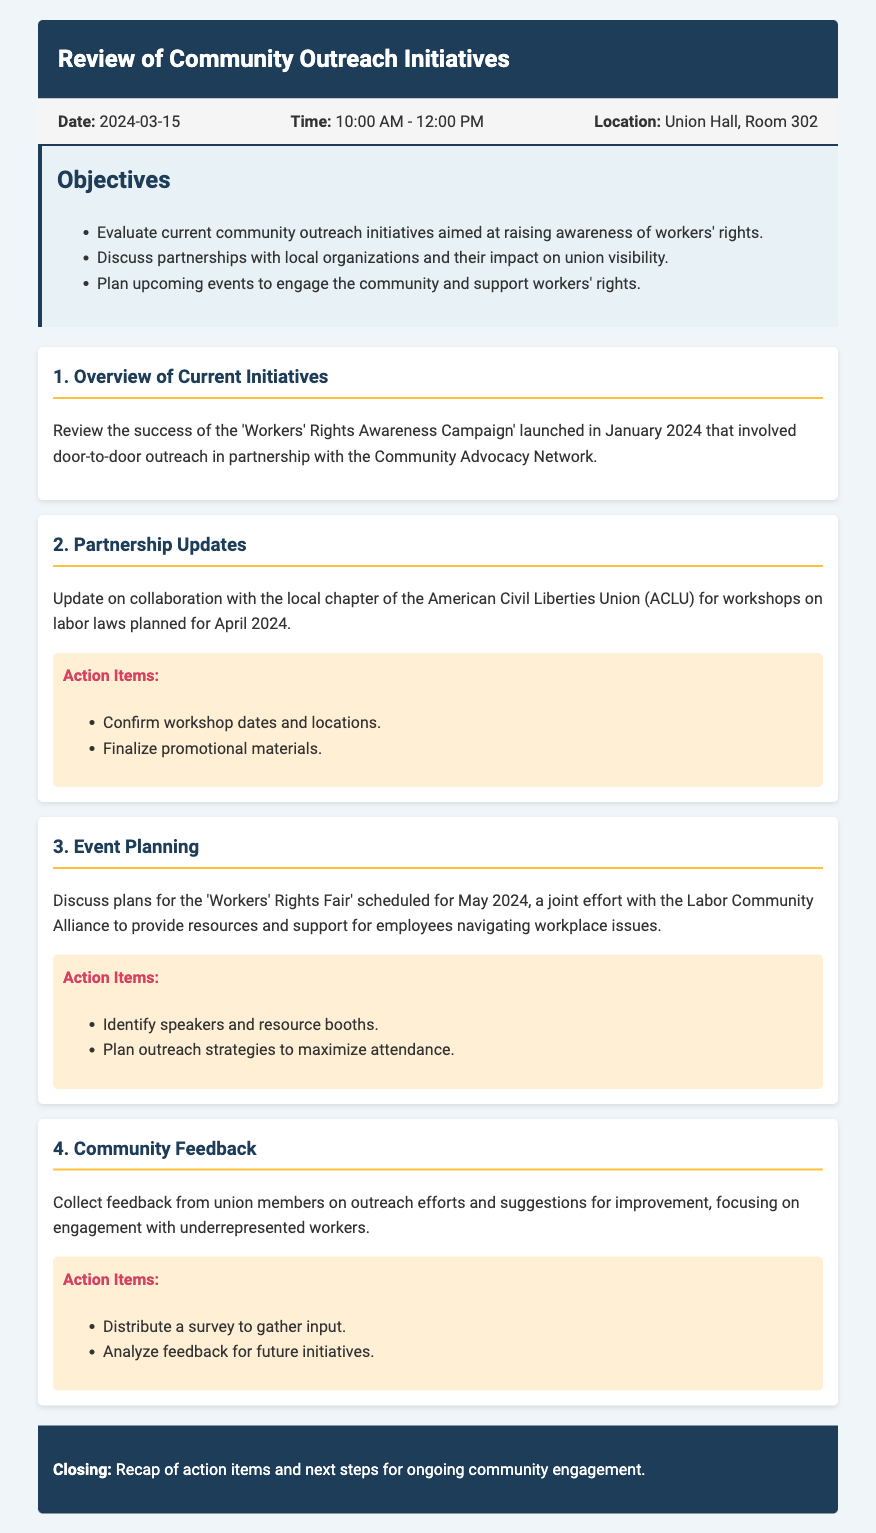What is the date of the meeting? The date of the meeting is stated in the meta-info section of the document.
Answer: 2024-03-15 What is the location of the meeting? The location of the meeting is mentioned in the meta-info section.
Answer: Union Hall, Room 302 What campaign was launched in January 2024? The overview of current initiatives mentions the name of the campaign launched in January.
Answer: Workers' Rights Awareness Campaign Who is collaborating with the union for workshops on labor laws? The partnership updates section specifies the organization the union is collaborating with.
Answer: American Civil Liberties Union (ACLU) What event is scheduled for May 2024? The event planning section indicates the name and timing of the event planned for May.
Answer: Workers' Rights Fair What is one of the action items related to community feedback? The action items under community feedback provide specific tasks related to gathering input.
Answer: Distribute a survey to gather input How did the union's outreach initiatives aim to support workers? The document states the purpose of the initiatives, which involves engagement with community members.
Answer: Raise awareness of workers' rights What type of feedback is being collected from union members? The community feedback item specifically mentions the focus of the feedback collection.
Answer: Suggestions for improvement What is one objective of the meeting? The objectives section lists the goals for this meeting.
Answer: Discuss partnerships with local organizations 